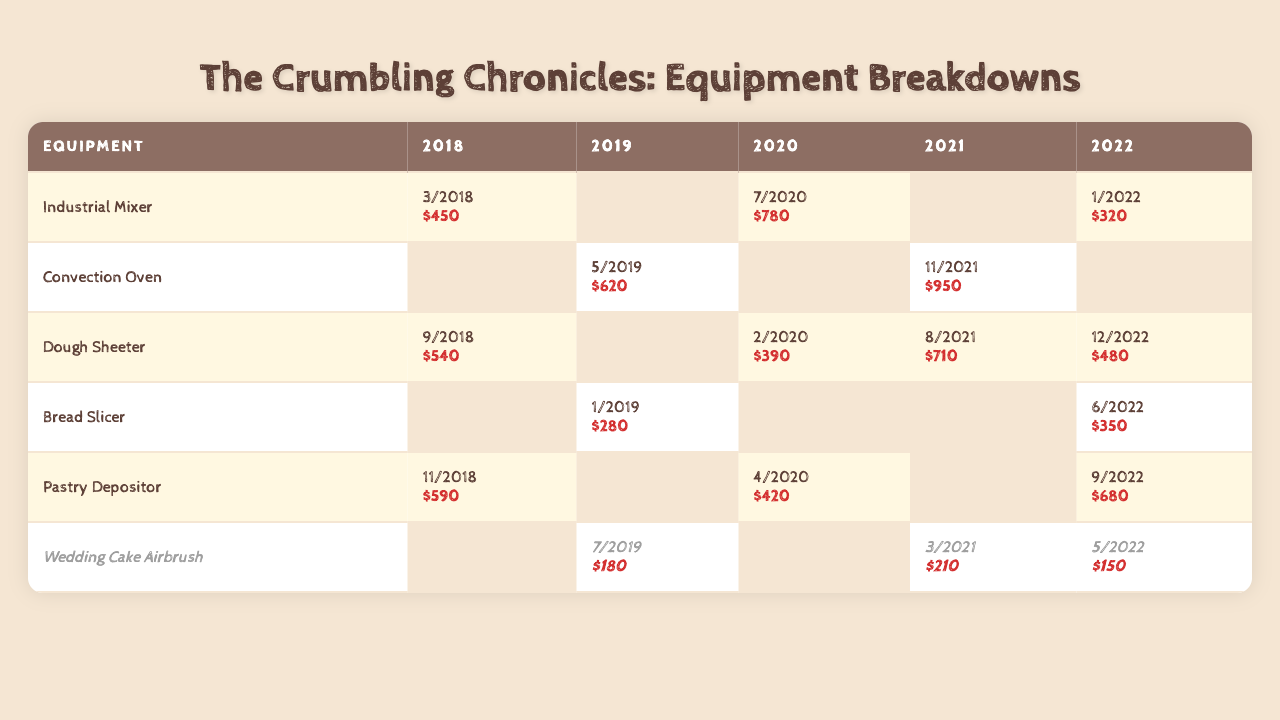What is the total repair cost for the Industrial Mixer? The Industrial Mixer has three recorded breakdowns: in 2018 ($450), 2020 ($780), and 2022 ($320). Summing these costs gives $450 + $780 + $320 = $1550.
Answer: $1550 Which equipment had the highest single repair cost in 2021? In 2021, the highest single repair cost was for the Convection Oven at $950.
Answer: Convection Oven How many times did the Dough Sheeter break down over the five-year period? The Dough Sheeter has four breakdown instances recorded: in 2018, 2020, 2021, and 2022, so it broke down four times.
Answer: 4 What was the total repair cost for all equipment in 2019? The repair costs in 2019 are as follows: Convection Oven ($620), Bread Slicer ($280), and Wedding Cake Airbrush ($180). Summing these gives $620 + $280 + $180 = $1080.
Answer: $1080 Is there any equipment that had a breakdown every year from 2018 to 2022? No, there is no equipment with recorded breakdowns for every year from 2018 to 2022. Each piece has gaps in their breakdown years.
Answer: No What is the average repair cost per breakdown for the Pastry Depositor? The Pastry Depositor had three breakdowns with costs of $590, $420, and $680. The average is calculated as ($590 + $420 + $680) / 3 = $563.33.
Answer: $563.33 Which year had the most breakdowns across all equipment? The year with the most breakdowns is 2021, with a total of four breakdowns: Dough Sheeter, Convection Oven, and Wedding Cake Airbrush.
Answer: 2021 What is the difference in total repair costs between the years 2020 and 2022? The total repair costs in 2020 were $780 (Industrial Mixer) + $390 (Dough Sheeter) + $420 (Pastry Depositor) = $1590. In 2022, totals were $320 (Industrial Mixer) + $480 (Dough Sheeter) + $350 (Bread Slicer) + $680 (Pastry Depositor) = $1830. The difference is $1830 - $1590 = $240.
Answer: $240 Which equipment had the least total repair cost over the five-year period? The Wedding Cake Airbrush had the least total repair cost with recorded expenses of $180, $210, and $150, summing to $540.
Answer: Wedding Cake Airbrush What is the combined repair cost for breakdowns in 2020 across all equipment? The combined repair costs for 2020 are $780 (Industrial Mixer), $390 (Dough Sheeter), and $420 (Pastry Depositor), totaling $780 + $390 + $420 = $1590.
Answer: $1590 